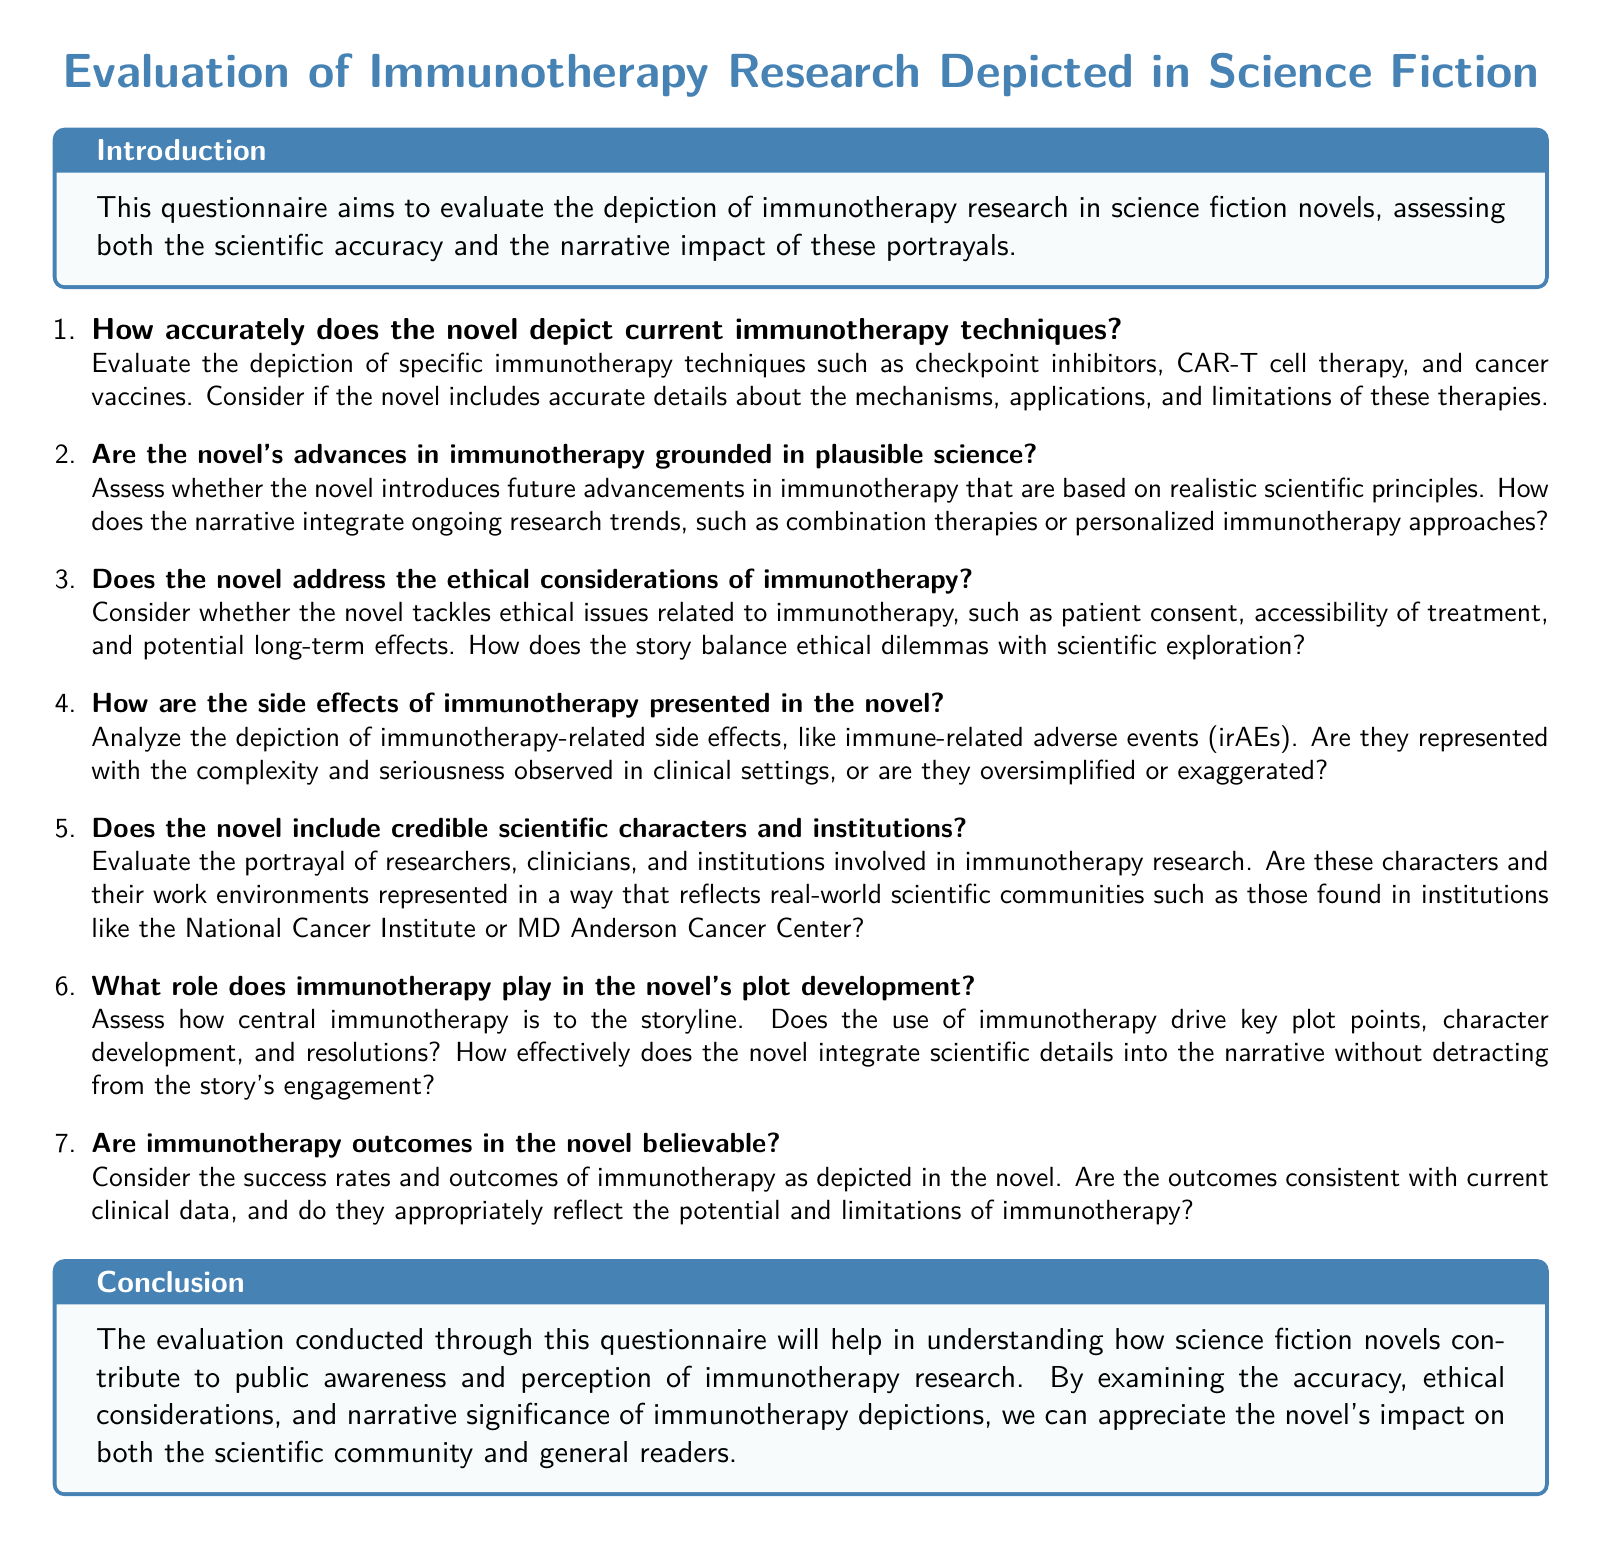What is the title of the document? The title is prominently displayed at the beginning of the document.
Answer: Evaluation of Immunotherapy Research Depicted in Science Fiction How many questions are included in the questionnaire? The document lists multiple questions sequentially; there are 7 questions in total.
Answer: 7 What is the color scheme used for the headers in the document? The document uses a specific color for headers that is mentioned in the code.
Answer: medblue What is the focus of the questionnaire? The introduction clearly states the purpose of the questionnaire.
Answer: To evaluate the depiction of immunotherapy research in science fiction novels Which immunotherapy techniques are specifically mentioned for evaluation? The document explicitly lists immunotherapy techniques to assess.
Answer: Checkpoint inhibitors, CAR-T cell therapy, and cancer vaccines Does the questionnaire address ethical considerations? One of the questions specifically asks about the ethical aspects related to immunotherapy.
Answer: Yes What type of environment does the document suggest researchers work in? The questionnaire prompts evaluation of characters' working environments in relation to real-world institutions.
Answer: Scientific communities How is the narrative impact of immunotherapy assessed? The questionnaire includes a question that focuses on the role of immunotherapy in plot development.
Answer: By assessing its centrality to the storyline 